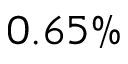<formula> <loc_0><loc_0><loc_500><loc_500>0 . 6 5 \%</formula> 